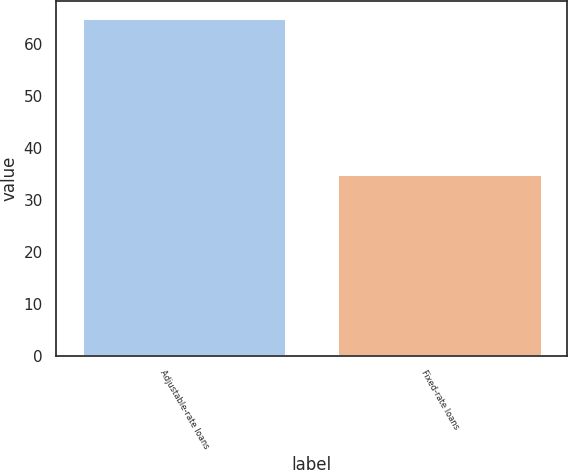Convert chart to OTSL. <chart><loc_0><loc_0><loc_500><loc_500><bar_chart><fcel>Adjustable-rate loans<fcel>Fixed-rate loans<nl><fcel>65<fcel>35<nl></chart> 